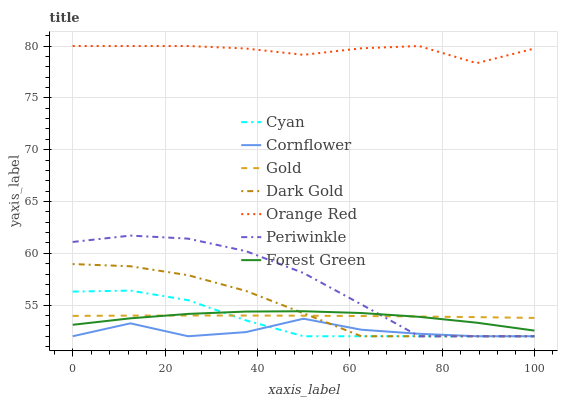Does Cornflower have the minimum area under the curve?
Answer yes or no. Yes. Does Orange Red have the maximum area under the curve?
Answer yes or no. Yes. Does Gold have the minimum area under the curve?
Answer yes or no. No. Does Gold have the maximum area under the curve?
Answer yes or no. No. Is Gold the smoothest?
Answer yes or no. Yes. Is Cornflower the roughest?
Answer yes or no. Yes. Is Dark Gold the smoothest?
Answer yes or no. No. Is Dark Gold the roughest?
Answer yes or no. No. Does Cornflower have the lowest value?
Answer yes or no. Yes. Does Gold have the lowest value?
Answer yes or no. No. Does Orange Red have the highest value?
Answer yes or no. Yes. Does Gold have the highest value?
Answer yes or no. No. Is Periwinkle less than Orange Red?
Answer yes or no. Yes. Is Orange Red greater than Gold?
Answer yes or no. Yes. Does Periwinkle intersect Forest Green?
Answer yes or no. Yes. Is Periwinkle less than Forest Green?
Answer yes or no. No. Is Periwinkle greater than Forest Green?
Answer yes or no. No. Does Periwinkle intersect Orange Red?
Answer yes or no. No. 